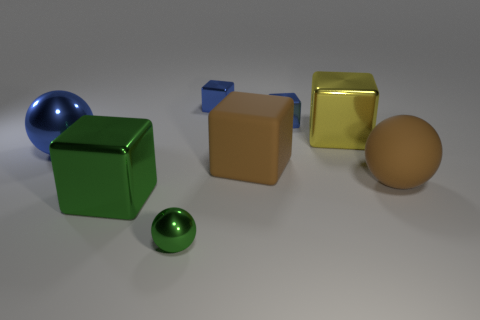Subtract all large brown spheres. How many spheres are left? 2 Subtract all brown spheres. How many spheres are left? 2 Subtract all cubes. How many objects are left? 3 Subtract all yellow spheres. How many blue cubes are left? 2 Subtract all big green things. Subtract all green balls. How many objects are left? 6 Add 3 small green metallic balls. How many small green metallic balls are left? 4 Add 3 tiny green shiny objects. How many tiny green shiny objects exist? 4 Add 1 small blue metal things. How many objects exist? 9 Subtract 0 yellow balls. How many objects are left? 8 Subtract 1 cubes. How many cubes are left? 4 